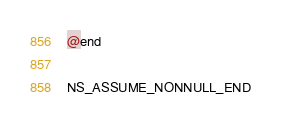Convert code to text. <code><loc_0><loc_0><loc_500><loc_500><_C_>
@end

NS_ASSUME_NONNULL_END
</code> 